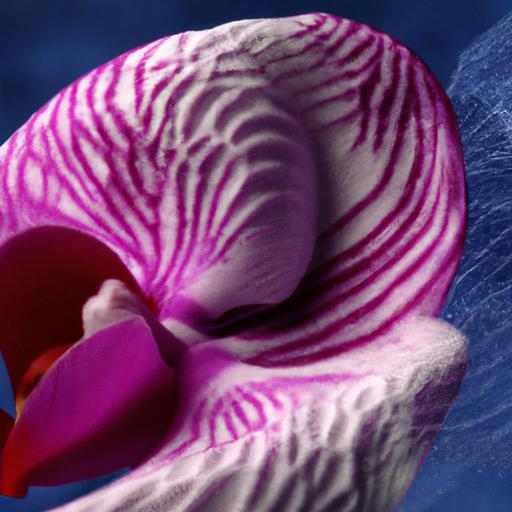Are there any overexposed areas in the image? Upon examination of the image, it appears that the lighting is well balanced with no noticeable overexposed areas. Each detail on the orchid's petals, from the vibrant pink hues to the delicate white patterns, is captured with clarity, indicating appropriate exposure levels. 